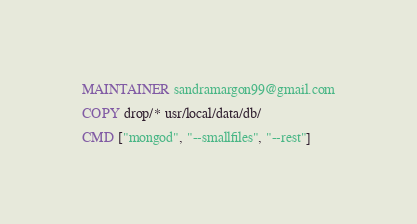<code> <loc_0><loc_0><loc_500><loc_500><_Dockerfile_>MAINTAINER sandramargon99@gmail.com

COPY drop/* usr/local/data/db/

CMD ["mongod", "--smallfiles", "--rest"]
</code> 